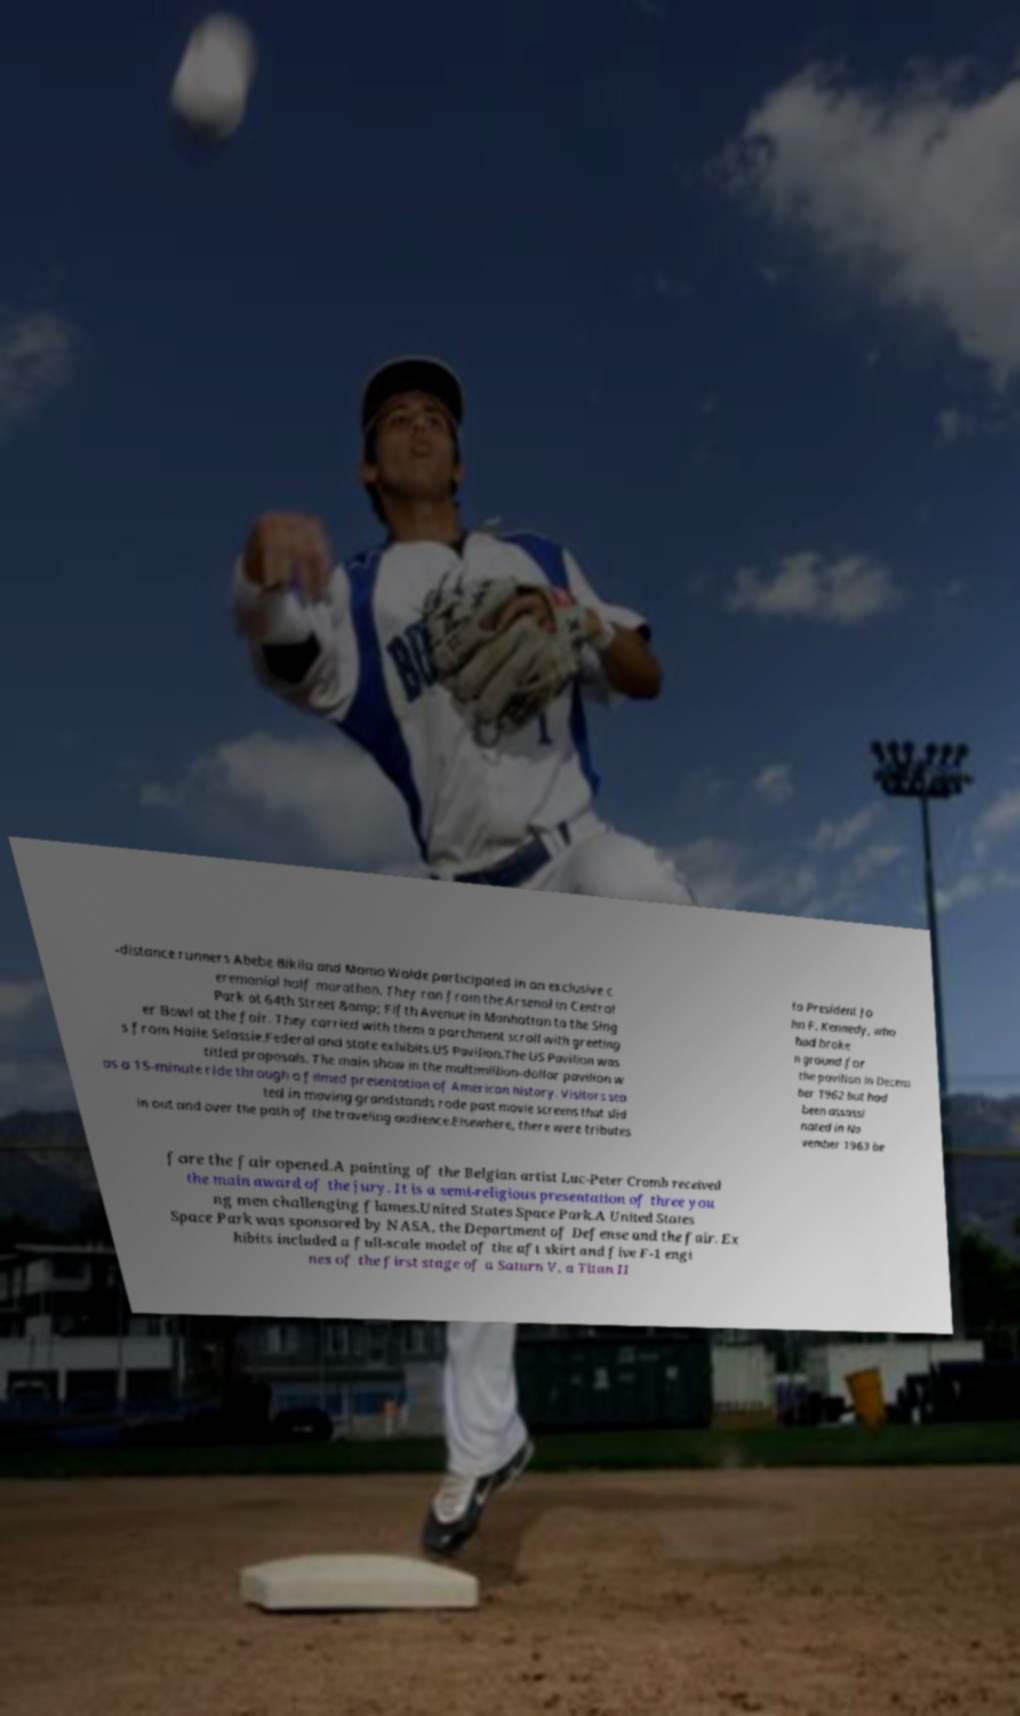Could you assist in decoding the text presented in this image and type it out clearly? -distance runners Abebe Bikila and Mamo Wolde participated in an exclusive c eremonial half marathon. They ran from the Arsenal in Central Park at 64th Street &amp; Fifth Avenue in Manhattan to the Sing er Bowl at the fair. They carried with them a parchment scroll with greeting s from Haile Selassie.Federal and state exhibits.US Pavilion.The US Pavilion was titled proposals. The main show in the multimillion-dollar pavilion w as a 15-minute ride through a filmed presentation of American history. Visitors sea ted in moving grandstands rode past movie screens that slid in out and over the path of the traveling audience.Elsewhere, there were tributes to President Jo hn F. Kennedy, who had broke n ground for the pavilion in Decem ber 1962 but had been assassi nated in No vember 1963 be fore the fair opened.A painting of the Belgian artist Luc-Peter Cromb received the main award of the jury. It is a semi-religious presentation of three you ng men challenging flames.United States Space Park.A United States Space Park was sponsored by NASA, the Department of Defense and the fair. Ex hibits included a full-scale model of the aft skirt and five F-1 engi nes of the first stage of a Saturn V, a Titan II 